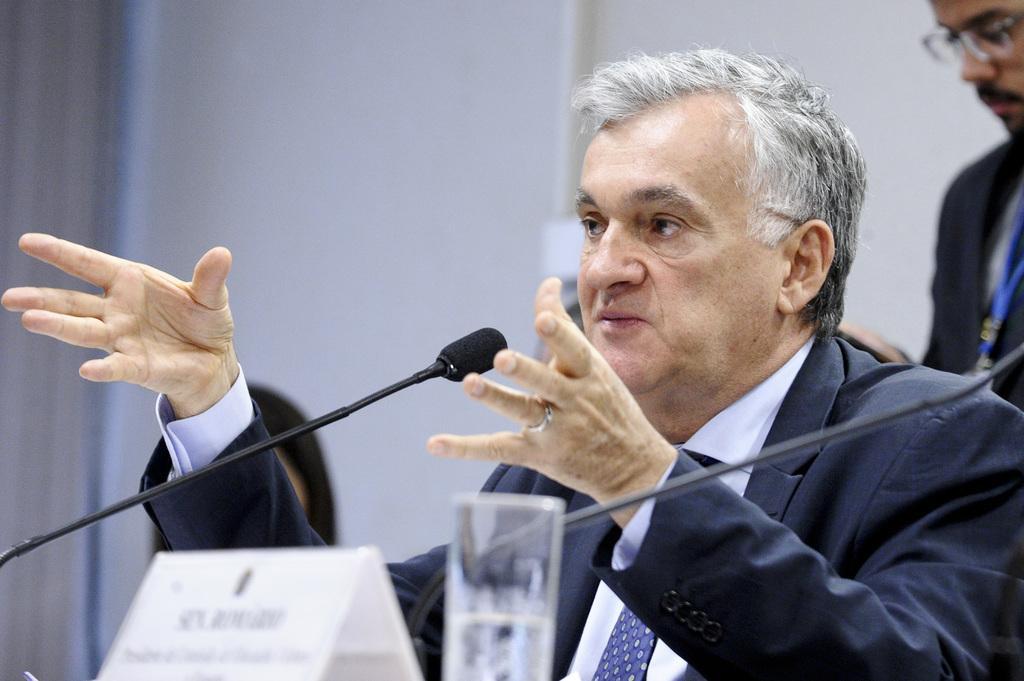Please provide a concise description of this image. In front of the image there is a person sitting in a chair, in front of him there are mic's, name board and a glass of water, beside him there are a few other people, behind him there is a person standing, in the background of the image there is a wall with a curtain. 